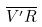Convert formula to latex. <formula><loc_0><loc_0><loc_500><loc_500>\overline { V ^ { \prime } R }</formula> 